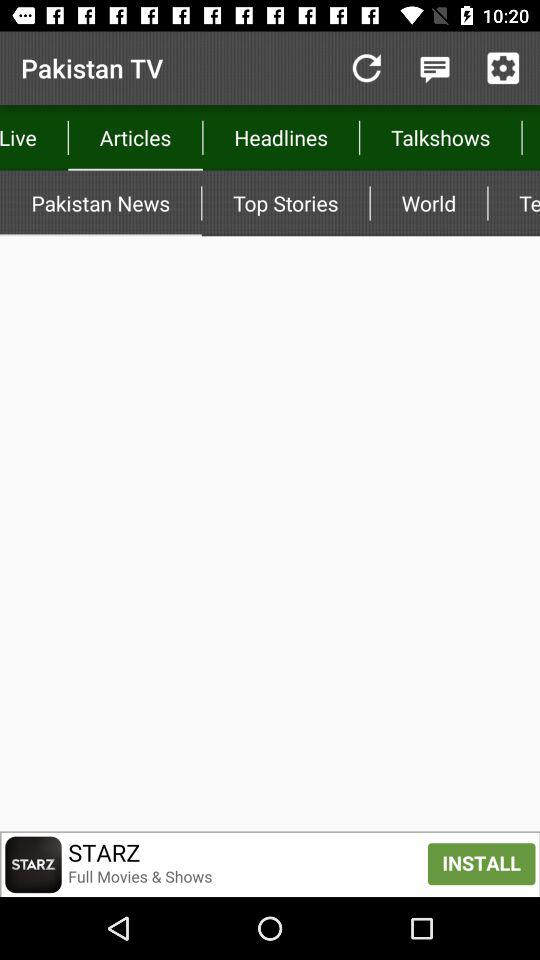Which stories are the top stories?
When the provided information is insufficient, respond with <no answer>. <no answer> 